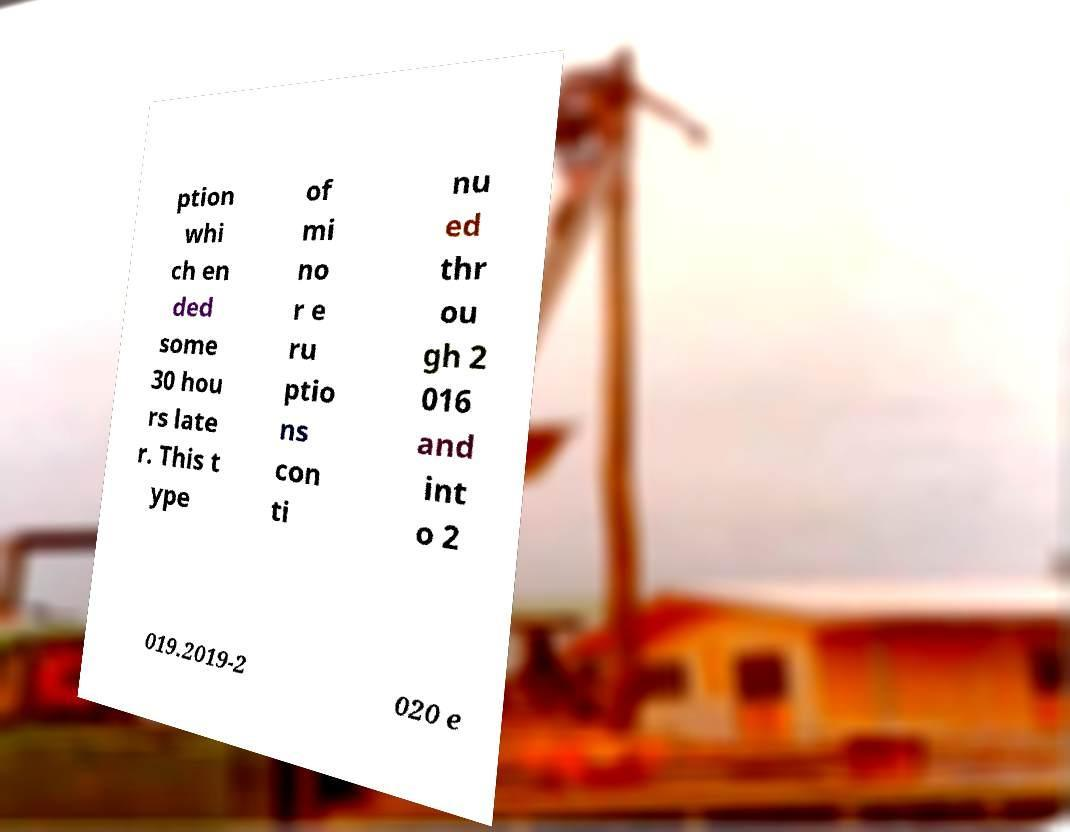Could you assist in decoding the text presented in this image and type it out clearly? ption whi ch en ded some 30 hou rs late r. This t ype of mi no r e ru ptio ns con ti nu ed thr ou gh 2 016 and int o 2 019.2019-2 020 e 